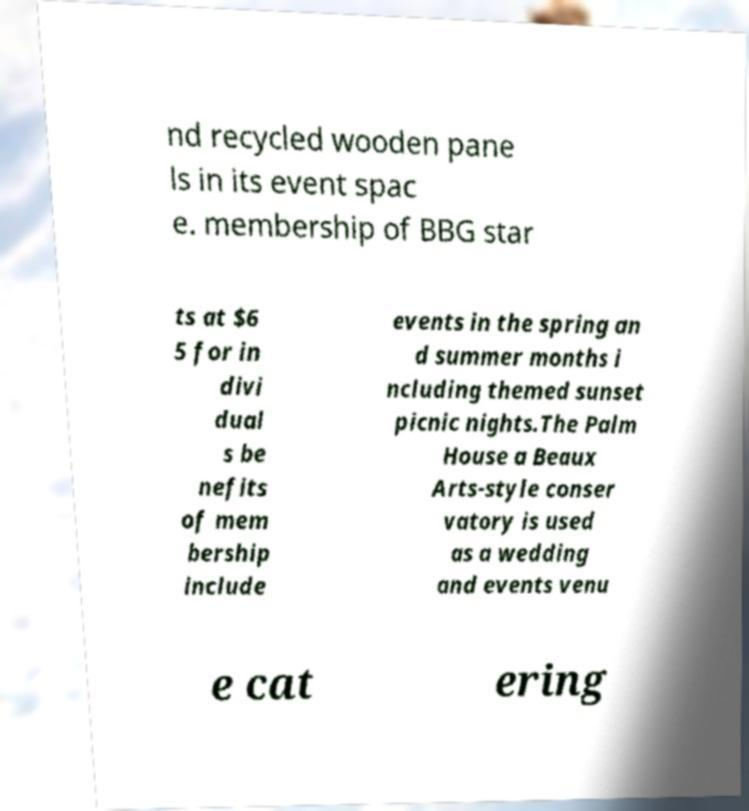What messages or text are displayed in this image? I need them in a readable, typed format. nd recycled wooden pane ls in its event spac e. membership of BBG star ts at $6 5 for in divi dual s be nefits of mem bership include events in the spring an d summer months i ncluding themed sunset picnic nights.The Palm House a Beaux Arts-style conser vatory is used as a wedding and events venu e cat ering 